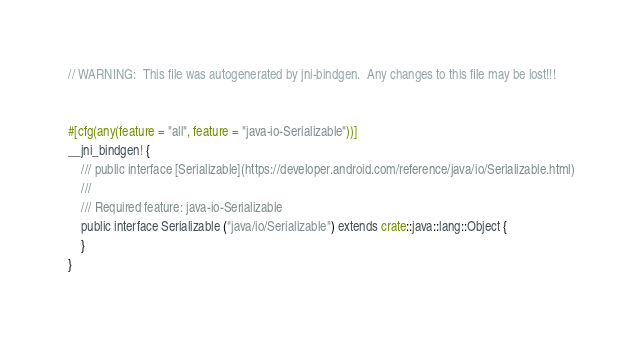Convert code to text. <code><loc_0><loc_0><loc_500><loc_500><_Rust_>// WARNING:  This file was autogenerated by jni-bindgen.  Any changes to this file may be lost!!!


#[cfg(any(feature = "all", feature = "java-io-Serializable"))]
__jni_bindgen! {
    /// public interface [Serializable](https://developer.android.com/reference/java/io/Serializable.html)
    ///
    /// Required feature: java-io-Serializable
    public interface Serializable ("java/io/Serializable") extends crate::java::lang::Object {
    }
}
</code> 